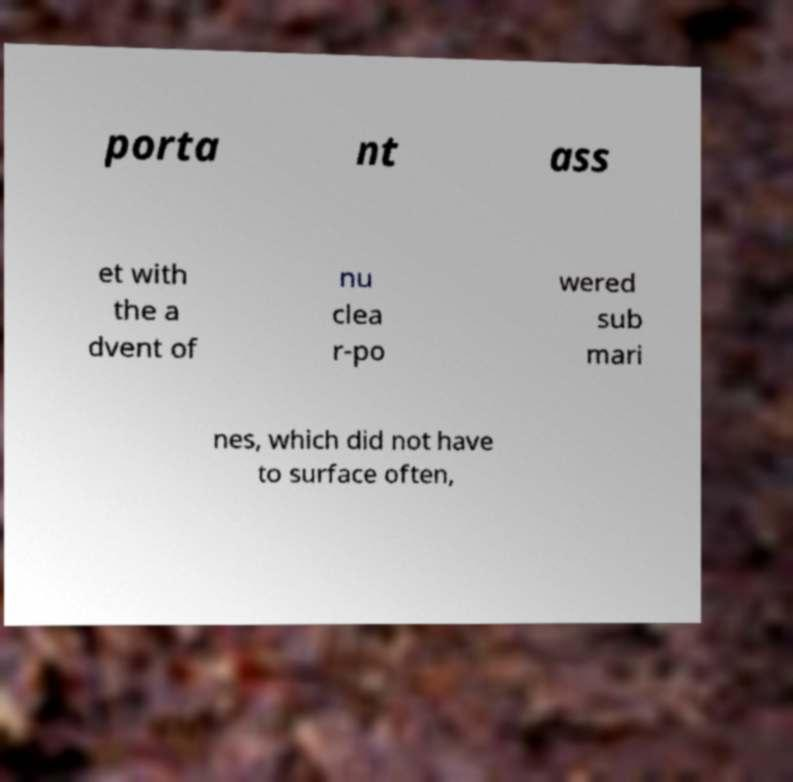Please identify and transcribe the text found in this image. porta nt ass et with the a dvent of nu clea r-po wered sub mari nes, which did not have to surface often, 